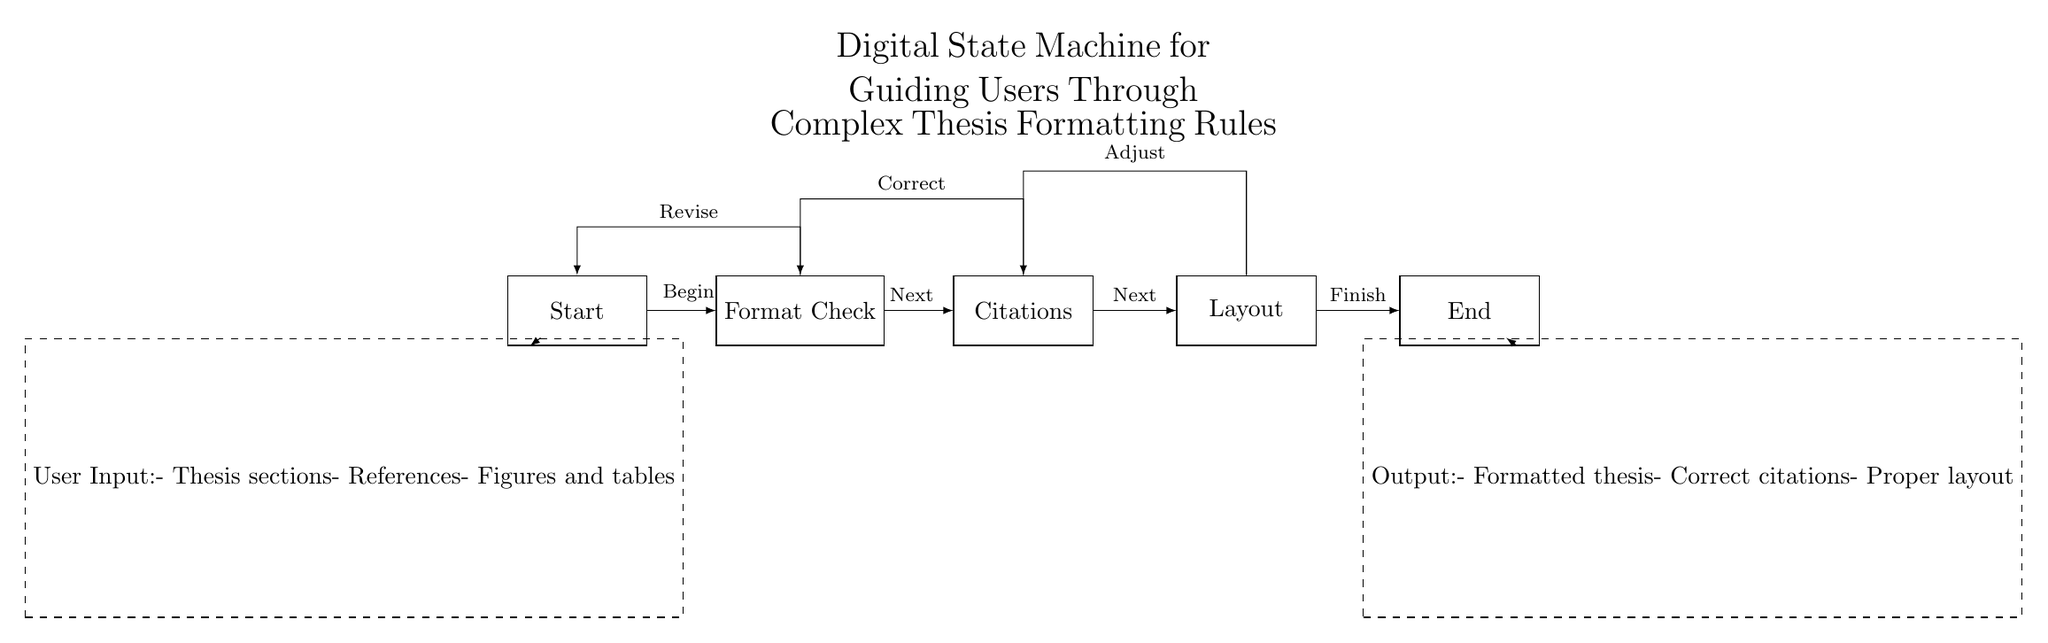What is the first state in the state machine? The first state in the state machine is labeled "Start", which indicates the initial point of the process for guiding users through formatting rules.
Answer: Start How many states are there in total? There are five states in the state machine: Start, Format Check, Citations, Layout, and End, which are interconnected sequentially.
Answer: Five What is the purpose of the "Format Check" state? The "Format Check" state serves as a review point to ensure that users correctly formatted their thesis before proceeding further in the workflow.
Answer: Review Which state is connected to "Citations" for feedback? The "Citations" state has a feedback loop that connects back to the "Format Check" state, indicating that corrections are needed before proceeding.
Answer: Format Check What do users provide as input to this digital state machine? Users provide input related to their thesis, including sections, references, and figures/tables, which the machine uses to guide them through formatting.
Answer: Thesis sections, references, figures and tables What outputs does the digital state machine produce? The outputs of the state machine consist of a formatted thesis, correct citations, and a proper layout, representing the final products after processing user input.
Answer: Formatted thesis, correct citations, proper layout 